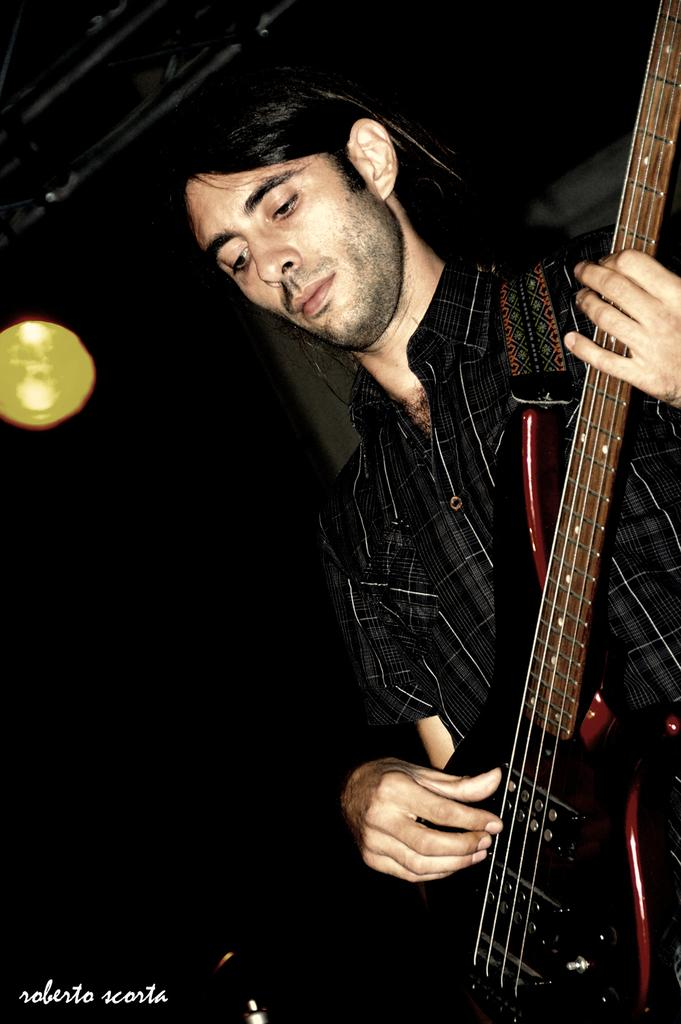What is the person in the image doing? The person is holding a guitar. What object is the person holding in the image? The person is holding a guitar. Is there any text or logo visible in the image? Yes, there is a watermark in the image. What can be seen in the background of the image? There are lights visible in the image. How many people are in the crowd surrounding the person with the guitar in the image? There is no crowd present in the image; it only features a person holding a guitar. What type of bait is being used to catch fish in the image? There is no fishing or bait present in the image; it only features a person holding a guitar. 